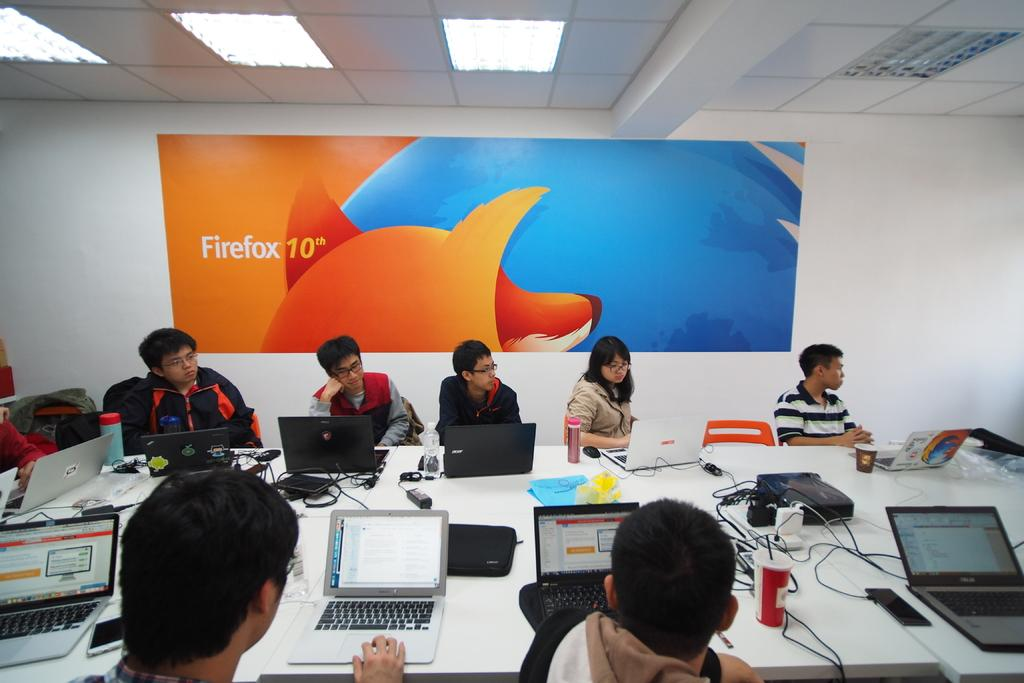<image>
Summarize the visual content of the image. A group of people sit around a conference table in front of a banner for Firefox 10th. 